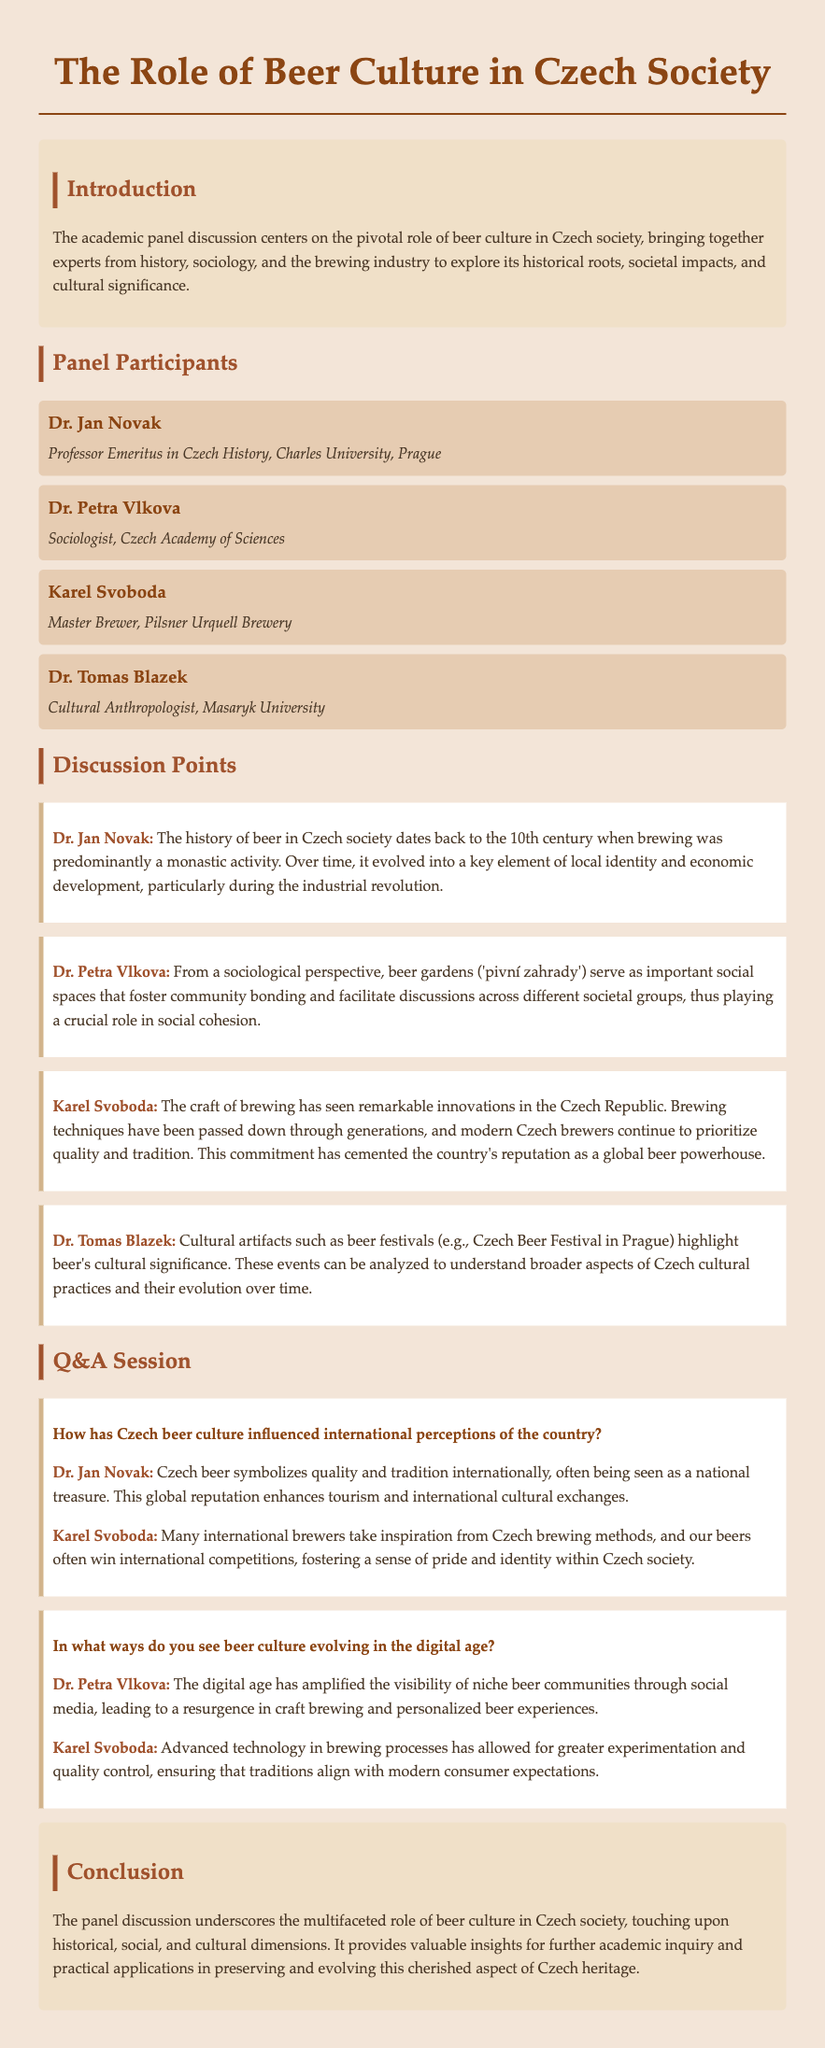What is the title of the panel discussion? The title of the panel discussion is mentioned at the top of the document.
Answer: The Role of Beer Culture in Czech Society Who is the Master Brewer at Pilsner Urquell Brewery? The document lists Karel Svoboda as the Master Brewer.
Answer: Karel Svoboda What century does the history of beer in Czech society date back to? Dr. Jan Novak states the history of beer dates back to the 10th century.
Answer: 10th century What type of spaces do beer gardens serve as, according to Dr. Petra Vlkova? Dr. Petra Vlkova describes beer gardens as important social spaces.
Answer: Social spaces How many panel participants are named in the document? The document lists four panel participants by name.
Answer: Four What is a cultural artifact mentioned by Dr. Tomas Blazek? Dr. Tomas Blazek refers to beer festivals as a cultural artifact.
Answer: Beer festivals What impact does Czech beer have on tourism according to Dr. Jan Novak? Dr. Jan Novak mentions that Czech beer enhances tourism.
Answer: Enhances tourism In what way has the digital age affected beer communities? Dr. Petra Vlkova says the digital age has amplified visibility of niche beer communities.
Answer: Amplified visibility 